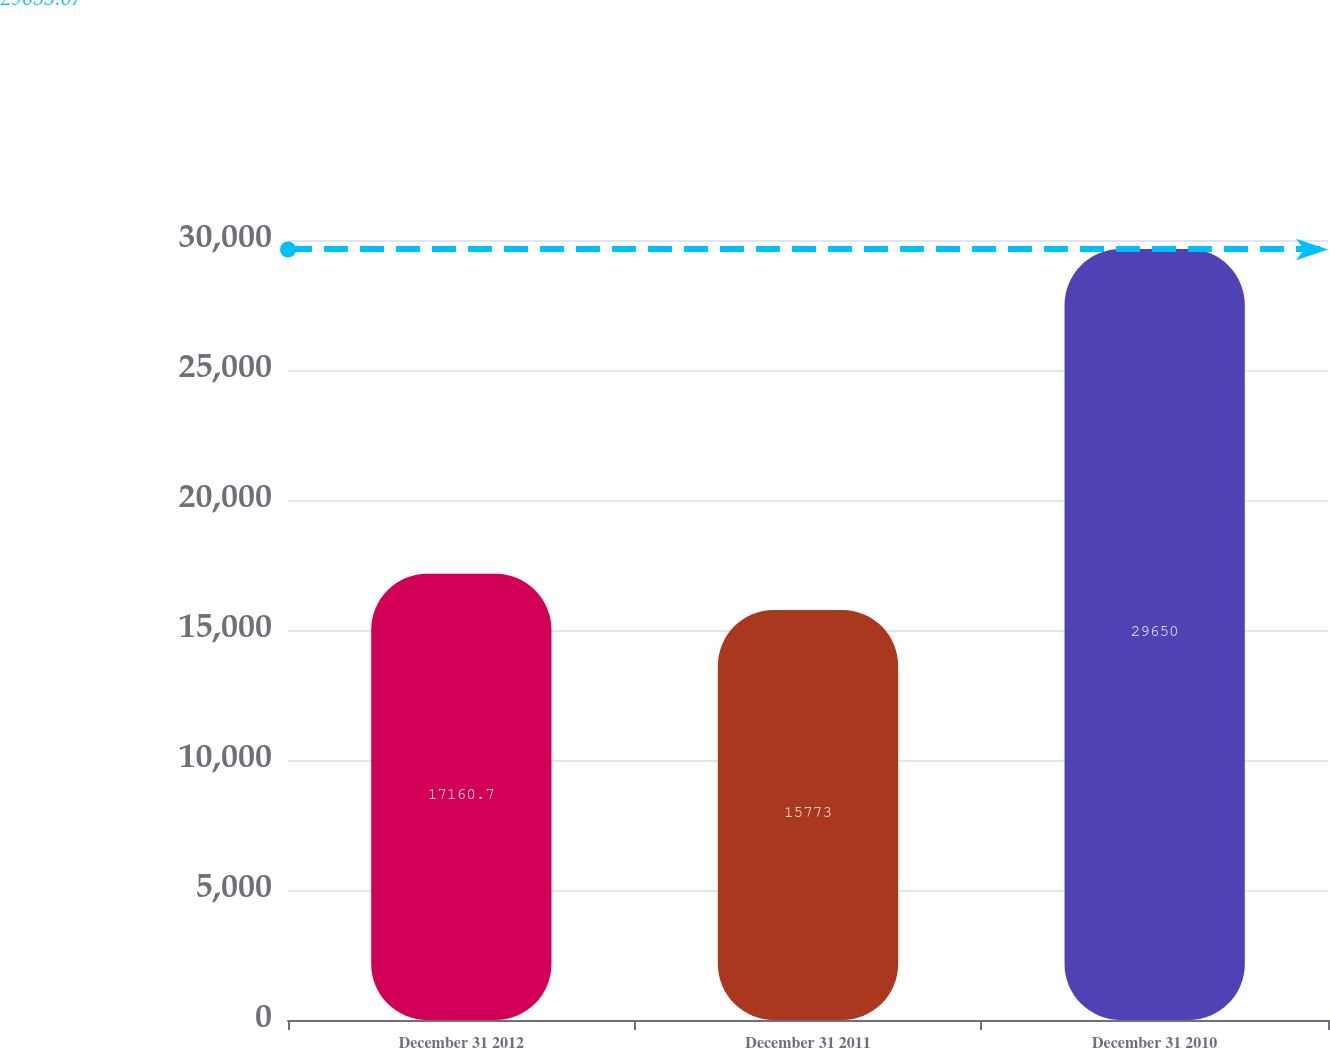<chart> <loc_0><loc_0><loc_500><loc_500><bar_chart><fcel>December 31 2012<fcel>December 31 2011<fcel>December 31 2010<nl><fcel>17160.7<fcel>15773<fcel>29650<nl></chart> 